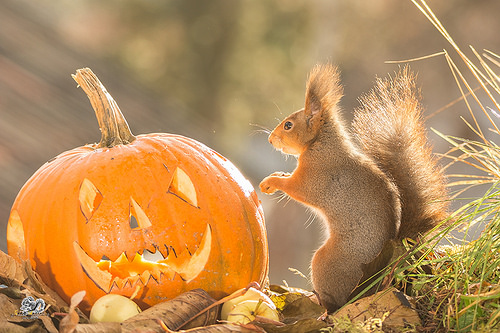<image>
Is the squirrel to the right of the pumpkin? Yes. From this viewpoint, the squirrel is positioned to the right side relative to the pumpkin. 